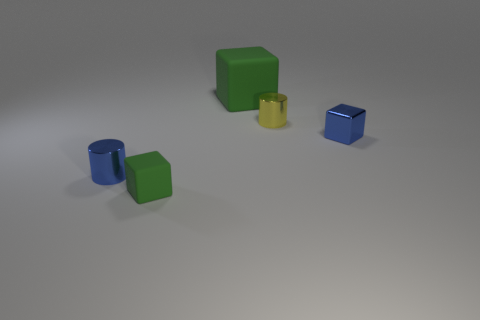What is the size of the other matte object that is the same shape as the tiny green object?
Provide a succinct answer. Large. What is the material of the blue block?
Provide a succinct answer. Metal. What material is the green block that is on the right side of the tiny green cube in front of the small yellow metallic cylinder on the right side of the tiny green object?
Provide a succinct answer. Rubber. Are there any other things that are the same shape as the large thing?
Provide a succinct answer. Yes. What is the color of the other metallic object that is the same shape as the yellow thing?
Provide a short and direct response. Blue. Does the tiny metal cylinder to the left of the tiny green object have the same color as the block on the right side of the big matte thing?
Provide a short and direct response. Yes. Is the number of metal cylinders to the right of the large green object greater than the number of small cyan balls?
Provide a succinct answer. Yes. How many other things are there of the same size as the yellow object?
Your answer should be compact. 3. How many objects are both on the right side of the tiny blue shiny cylinder and behind the tiny green thing?
Your answer should be very brief. 3. Does the small cylinder that is to the left of the small green object have the same material as the small green cube?
Ensure brevity in your answer.  No. 